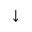<formula> <loc_0><loc_0><loc_500><loc_500>\downarrow</formula> 